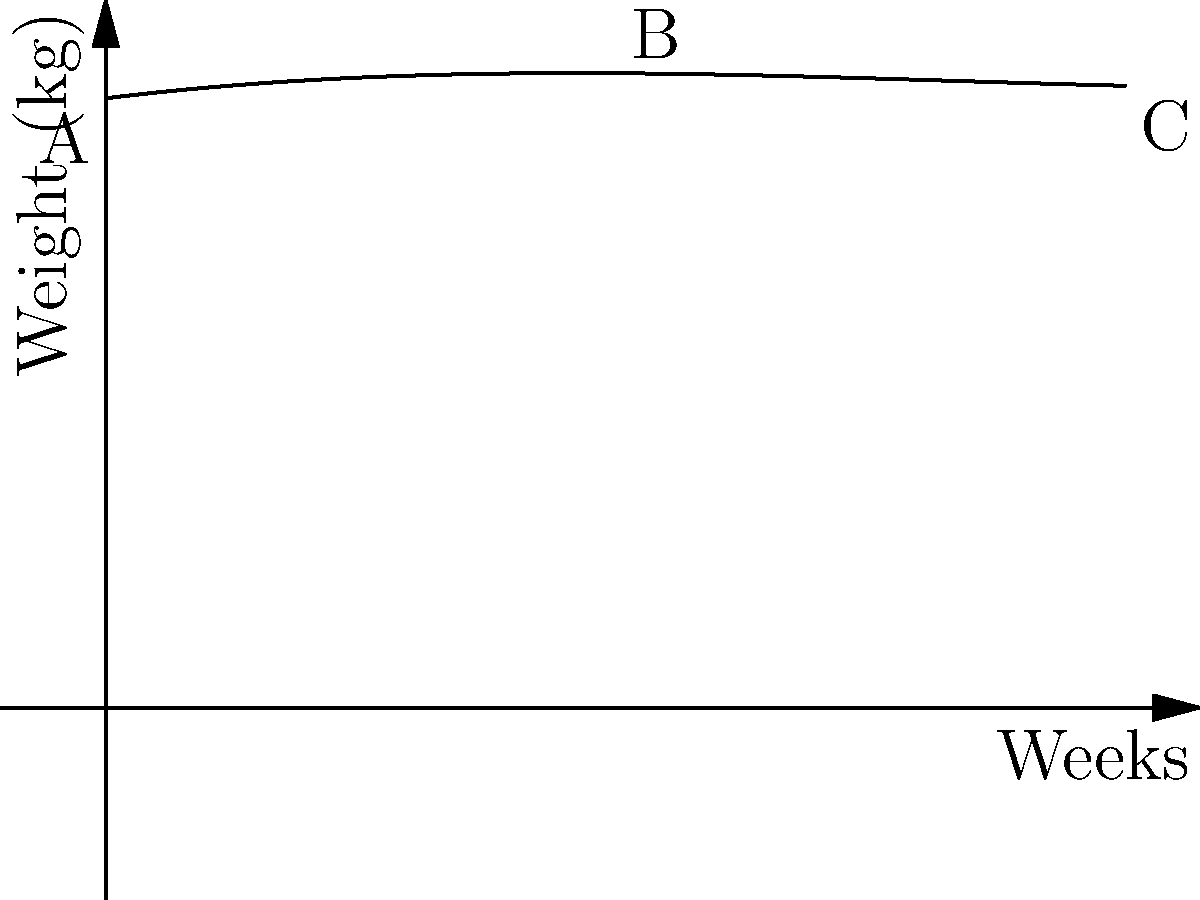The graph shows the relationship between calorie intake and weight change over a 12-week period for a client. If point A represents the initial weight, point B the lowest weight, and point C the final weight, what is the approximate total weight change from the start to the end of the 12-week period? To determine the total weight change, we need to follow these steps:

1. Identify the initial weight (point A) and final weight (point C).
2. Calculate the difference between these two weights.

From the graph:
1. Point A (initial weight) is at approximately 70 kg.
2. Point C (final weight) is at approximately 73 kg.

The weight change is calculated as:
$$\text{Weight change} = \text{Final weight} - \text{Initial weight}$$
$$= 73 \text{ kg} - 70 \text{ kg} = 3 \text{ kg}$$

Therefore, the total weight change from the start to the end of the 12-week period is an increase of approximately 3 kg.
Answer: 3 kg increase 